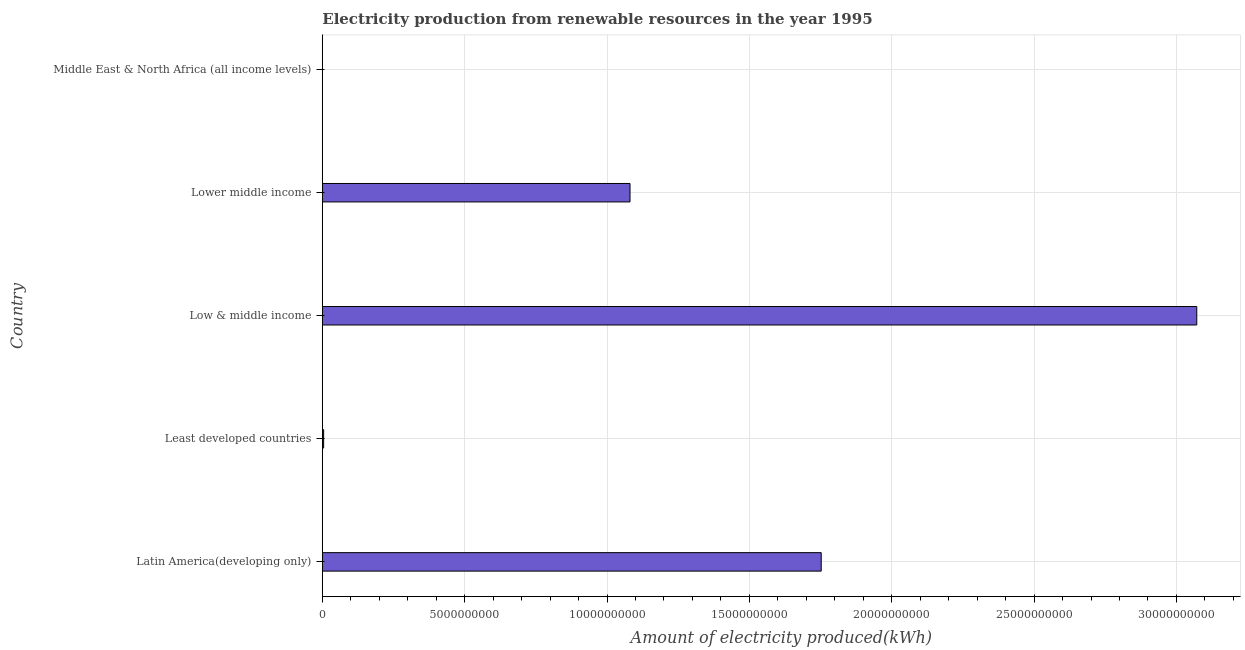Does the graph contain grids?
Ensure brevity in your answer.  Yes. What is the title of the graph?
Ensure brevity in your answer.  Electricity production from renewable resources in the year 1995. What is the label or title of the X-axis?
Your answer should be compact. Amount of electricity produced(kWh). What is the label or title of the Y-axis?
Offer a terse response. Country. What is the amount of electricity produced in Low & middle income?
Your response must be concise. 3.07e+1. Across all countries, what is the maximum amount of electricity produced?
Provide a short and direct response. 3.07e+1. In which country was the amount of electricity produced minimum?
Ensure brevity in your answer.  Middle East & North Africa (all income levels). What is the sum of the amount of electricity produced?
Offer a very short reply. 5.91e+1. What is the difference between the amount of electricity produced in Low & middle income and Lower middle income?
Give a very brief answer. 1.99e+1. What is the average amount of electricity produced per country?
Provide a succinct answer. 1.18e+1. What is the median amount of electricity produced?
Keep it short and to the point. 1.08e+1. What is the ratio of the amount of electricity produced in Low & middle income to that in Lower middle income?
Provide a short and direct response. 2.84. What is the difference between the highest and the second highest amount of electricity produced?
Your answer should be very brief. 1.32e+1. What is the difference between the highest and the lowest amount of electricity produced?
Keep it short and to the point. 3.07e+1. In how many countries, is the amount of electricity produced greater than the average amount of electricity produced taken over all countries?
Give a very brief answer. 2. How many bars are there?
Provide a succinct answer. 5. Are all the bars in the graph horizontal?
Your answer should be very brief. Yes. How many countries are there in the graph?
Make the answer very short. 5. What is the difference between two consecutive major ticks on the X-axis?
Give a very brief answer. 5.00e+09. Are the values on the major ticks of X-axis written in scientific E-notation?
Offer a terse response. No. What is the Amount of electricity produced(kWh) of Latin America(developing only)?
Make the answer very short. 1.75e+1. What is the Amount of electricity produced(kWh) in Least developed countries?
Your answer should be compact. 4.60e+07. What is the Amount of electricity produced(kWh) of Low & middle income?
Ensure brevity in your answer.  3.07e+1. What is the Amount of electricity produced(kWh) in Lower middle income?
Ensure brevity in your answer.  1.08e+1. What is the difference between the Amount of electricity produced(kWh) in Latin America(developing only) and Least developed countries?
Make the answer very short. 1.75e+1. What is the difference between the Amount of electricity produced(kWh) in Latin America(developing only) and Low & middle income?
Keep it short and to the point. -1.32e+1. What is the difference between the Amount of electricity produced(kWh) in Latin America(developing only) and Lower middle income?
Make the answer very short. 6.72e+09. What is the difference between the Amount of electricity produced(kWh) in Latin America(developing only) and Middle East & North Africa (all income levels)?
Your answer should be very brief. 1.75e+1. What is the difference between the Amount of electricity produced(kWh) in Least developed countries and Low & middle income?
Make the answer very short. -3.07e+1. What is the difference between the Amount of electricity produced(kWh) in Least developed countries and Lower middle income?
Offer a terse response. -1.08e+1. What is the difference between the Amount of electricity produced(kWh) in Least developed countries and Middle East & North Africa (all income levels)?
Your answer should be very brief. 4.50e+07. What is the difference between the Amount of electricity produced(kWh) in Low & middle income and Lower middle income?
Offer a terse response. 1.99e+1. What is the difference between the Amount of electricity produced(kWh) in Low & middle income and Middle East & North Africa (all income levels)?
Provide a succinct answer. 3.07e+1. What is the difference between the Amount of electricity produced(kWh) in Lower middle income and Middle East & North Africa (all income levels)?
Make the answer very short. 1.08e+1. What is the ratio of the Amount of electricity produced(kWh) in Latin America(developing only) to that in Least developed countries?
Your response must be concise. 380.94. What is the ratio of the Amount of electricity produced(kWh) in Latin America(developing only) to that in Low & middle income?
Your response must be concise. 0.57. What is the ratio of the Amount of electricity produced(kWh) in Latin America(developing only) to that in Lower middle income?
Your answer should be very brief. 1.62. What is the ratio of the Amount of electricity produced(kWh) in Latin America(developing only) to that in Middle East & North Africa (all income levels)?
Offer a terse response. 1.75e+04. What is the ratio of the Amount of electricity produced(kWh) in Least developed countries to that in Lower middle income?
Make the answer very short. 0. What is the ratio of the Amount of electricity produced(kWh) in Low & middle income to that in Lower middle income?
Ensure brevity in your answer.  2.84. What is the ratio of the Amount of electricity produced(kWh) in Low & middle income to that in Middle East & North Africa (all income levels)?
Offer a terse response. 3.07e+04. What is the ratio of the Amount of electricity produced(kWh) in Lower middle income to that in Middle East & North Africa (all income levels)?
Provide a succinct answer. 1.08e+04. 